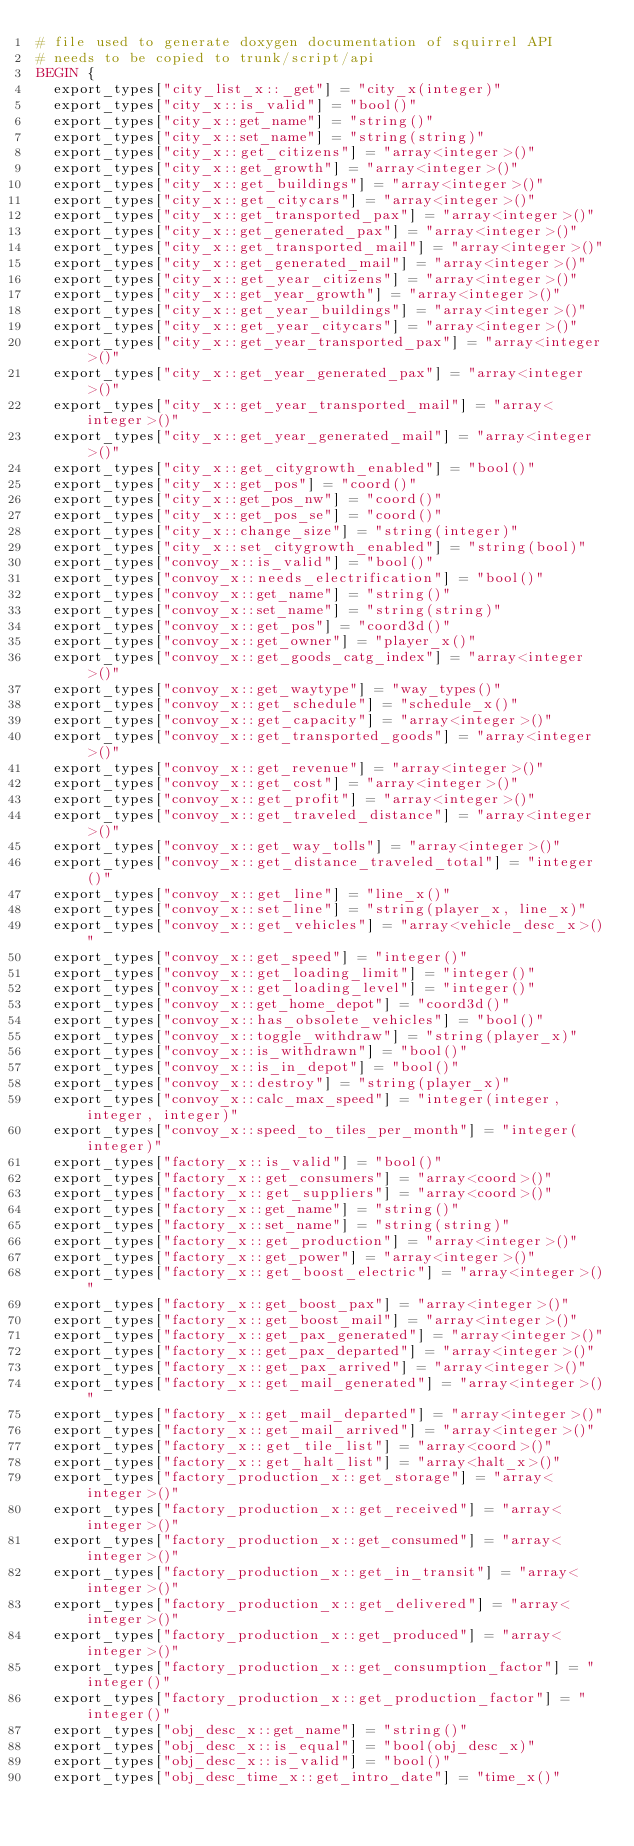Convert code to text. <code><loc_0><loc_0><loc_500><loc_500><_Awk_># file used to generate doxygen documentation of squirrel API
# needs to be copied to trunk/script/api
BEGIN {
	export_types["city_list_x::_get"] = "city_x(integer)"
	export_types["city_x::is_valid"] = "bool()"
	export_types["city_x::get_name"] = "string()"
	export_types["city_x::set_name"] = "string(string)"
	export_types["city_x::get_citizens"] = "array<integer>()"
	export_types["city_x::get_growth"] = "array<integer>()"
	export_types["city_x::get_buildings"] = "array<integer>()"
	export_types["city_x::get_citycars"] = "array<integer>()"
	export_types["city_x::get_transported_pax"] = "array<integer>()"
	export_types["city_x::get_generated_pax"] = "array<integer>()"
	export_types["city_x::get_transported_mail"] = "array<integer>()"
	export_types["city_x::get_generated_mail"] = "array<integer>()"
	export_types["city_x::get_year_citizens"] = "array<integer>()"
	export_types["city_x::get_year_growth"] = "array<integer>()"
	export_types["city_x::get_year_buildings"] = "array<integer>()"
	export_types["city_x::get_year_citycars"] = "array<integer>()"
	export_types["city_x::get_year_transported_pax"] = "array<integer>()"
	export_types["city_x::get_year_generated_pax"] = "array<integer>()"
	export_types["city_x::get_year_transported_mail"] = "array<integer>()"
	export_types["city_x::get_year_generated_mail"] = "array<integer>()"
	export_types["city_x::get_citygrowth_enabled"] = "bool()"
	export_types["city_x::get_pos"] = "coord()"
	export_types["city_x::get_pos_nw"] = "coord()"
	export_types["city_x::get_pos_se"] = "coord()"
	export_types["city_x::change_size"] = "string(integer)"
	export_types["city_x::set_citygrowth_enabled"] = "string(bool)"
	export_types["convoy_x::is_valid"] = "bool()"
	export_types["convoy_x::needs_electrification"] = "bool()"
	export_types["convoy_x::get_name"] = "string()"
	export_types["convoy_x::set_name"] = "string(string)"
	export_types["convoy_x::get_pos"] = "coord3d()"
	export_types["convoy_x::get_owner"] = "player_x()"
	export_types["convoy_x::get_goods_catg_index"] = "array<integer>()"
	export_types["convoy_x::get_waytype"] = "way_types()"
	export_types["convoy_x::get_schedule"] = "schedule_x()"
	export_types["convoy_x::get_capacity"] = "array<integer>()"
	export_types["convoy_x::get_transported_goods"] = "array<integer>()"
	export_types["convoy_x::get_revenue"] = "array<integer>()"
	export_types["convoy_x::get_cost"] = "array<integer>()"
	export_types["convoy_x::get_profit"] = "array<integer>()"
	export_types["convoy_x::get_traveled_distance"] = "array<integer>()"
	export_types["convoy_x::get_way_tolls"] = "array<integer>()"
	export_types["convoy_x::get_distance_traveled_total"] = "integer()"
	export_types["convoy_x::get_line"] = "line_x()"
	export_types["convoy_x::set_line"] = "string(player_x, line_x)"
	export_types["convoy_x::get_vehicles"] = "array<vehicle_desc_x>()"
	export_types["convoy_x::get_speed"] = "integer()"
	export_types["convoy_x::get_loading_limit"] = "integer()"
	export_types["convoy_x::get_loading_level"] = "integer()"
	export_types["convoy_x::get_home_depot"] = "coord3d()"
	export_types["convoy_x::has_obsolete_vehicles"] = "bool()"
	export_types["convoy_x::toggle_withdraw"] = "string(player_x)"
	export_types["convoy_x::is_withdrawn"] = "bool()"
	export_types["convoy_x::is_in_depot"] = "bool()"
	export_types["convoy_x::destroy"] = "string(player_x)"
	export_types["convoy_x::calc_max_speed"] = "integer(integer, integer, integer)"
	export_types["convoy_x::speed_to_tiles_per_month"] = "integer(integer)"
	export_types["factory_x::is_valid"] = "bool()"
	export_types["factory_x::get_consumers"] = "array<coord>()"
	export_types["factory_x::get_suppliers"] = "array<coord>()"
	export_types["factory_x::get_name"] = "string()"
	export_types["factory_x::set_name"] = "string(string)"
	export_types["factory_x::get_production"] = "array<integer>()"
	export_types["factory_x::get_power"] = "array<integer>()"
	export_types["factory_x::get_boost_electric"] = "array<integer>()"
	export_types["factory_x::get_boost_pax"] = "array<integer>()"
	export_types["factory_x::get_boost_mail"] = "array<integer>()"
	export_types["factory_x::get_pax_generated"] = "array<integer>()"
	export_types["factory_x::get_pax_departed"] = "array<integer>()"
	export_types["factory_x::get_pax_arrived"] = "array<integer>()"
	export_types["factory_x::get_mail_generated"] = "array<integer>()"
	export_types["factory_x::get_mail_departed"] = "array<integer>()"
	export_types["factory_x::get_mail_arrived"] = "array<integer>()"
	export_types["factory_x::get_tile_list"] = "array<coord>()"
	export_types["factory_x::get_halt_list"] = "array<halt_x>()"
	export_types["factory_production_x::get_storage"] = "array<integer>()"
	export_types["factory_production_x::get_received"] = "array<integer>()"
	export_types["factory_production_x::get_consumed"] = "array<integer>()"
	export_types["factory_production_x::get_in_transit"] = "array<integer>()"
	export_types["factory_production_x::get_delivered"] = "array<integer>()"
	export_types["factory_production_x::get_produced"] = "array<integer>()"
	export_types["factory_production_x::get_consumption_factor"] = "integer()"
	export_types["factory_production_x::get_production_factor"] = "integer()"
	export_types["obj_desc_x::get_name"] = "string()"
	export_types["obj_desc_x::is_equal"] = "bool(obj_desc_x)"
	export_types["obj_desc_x::is_valid"] = "bool()"
	export_types["obj_desc_time_x::get_intro_date"] = "time_x()"</code> 